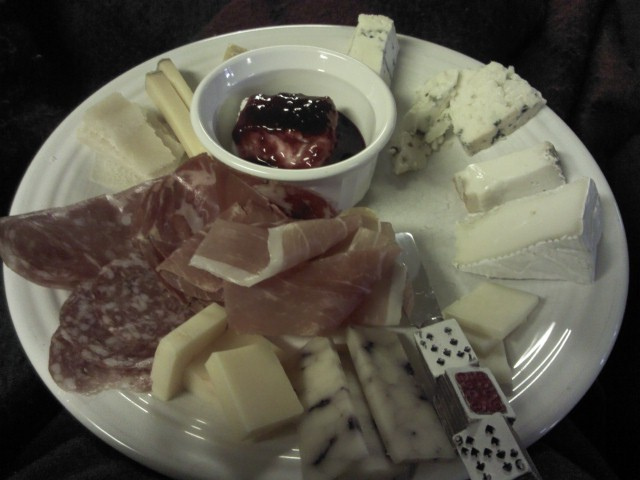Could you explain the process of making the type of cheese that is speckled with blue? Certainly! The blue-speckled cheese on the plate is a type of blue cheese. The process of making blue cheese involves introducing Penicillium cultures to the cheese curds. These cultures are responsible for the characteristic veining and strong flavor profile. The cheese is then aged in a temperature and humidity-controlled environment, allowing the mold to grow and the flavors to develop. 